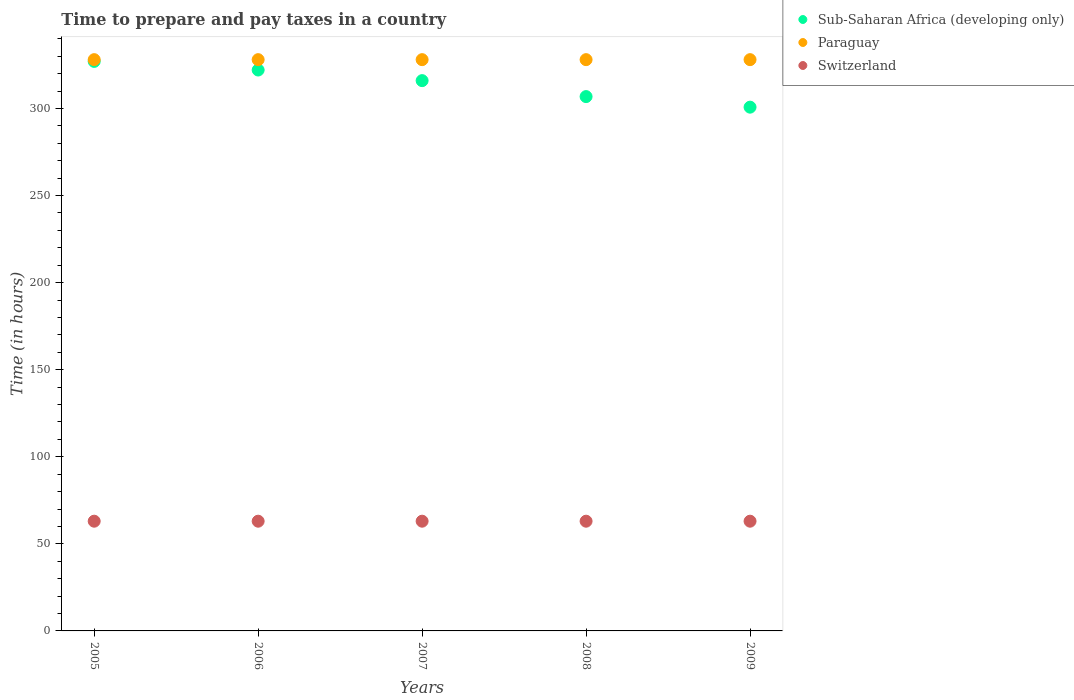How many different coloured dotlines are there?
Make the answer very short. 3. What is the number of hours required to prepare and pay taxes in Switzerland in 2006?
Offer a terse response. 63. Across all years, what is the maximum number of hours required to prepare and pay taxes in Sub-Saharan Africa (developing only)?
Make the answer very short. 327. Across all years, what is the minimum number of hours required to prepare and pay taxes in Sub-Saharan Africa (developing only)?
Your answer should be compact. 300.72. In which year was the number of hours required to prepare and pay taxes in Paraguay maximum?
Keep it short and to the point. 2005. What is the total number of hours required to prepare and pay taxes in Sub-Saharan Africa (developing only) in the graph?
Your answer should be very brief. 1572.51. What is the difference between the number of hours required to prepare and pay taxes in Switzerland in 2007 and that in 2008?
Offer a terse response. 0. What is the difference between the number of hours required to prepare and pay taxes in Switzerland in 2006 and the number of hours required to prepare and pay taxes in Paraguay in 2005?
Offer a very short reply. -265. What is the average number of hours required to prepare and pay taxes in Sub-Saharan Africa (developing only) per year?
Your response must be concise. 314.5. In the year 2006, what is the difference between the number of hours required to prepare and pay taxes in Sub-Saharan Africa (developing only) and number of hours required to prepare and pay taxes in Switzerland?
Offer a very short reply. 259.05. In how many years, is the number of hours required to prepare and pay taxes in Switzerland greater than 210 hours?
Give a very brief answer. 0. What is the ratio of the number of hours required to prepare and pay taxes in Paraguay in 2008 to that in 2009?
Your response must be concise. 1. Is the number of hours required to prepare and pay taxes in Paraguay in 2005 less than that in 2007?
Ensure brevity in your answer.  No. What is the difference between the highest and the lowest number of hours required to prepare and pay taxes in Switzerland?
Your answer should be compact. 0. In how many years, is the number of hours required to prepare and pay taxes in Paraguay greater than the average number of hours required to prepare and pay taxes in Paraguay taken over all years?
Make the answer very short. 0. Is the sum of the number of hours required to prepare and pay taxes in Switzerland in 2008 and 2009 greater than the maximum number of hours required to prepare and pay taxes in Sub-Saharan Africa (developing only) across all years?
Offer a terse response. No. Is the number of hours required to prepare and pay taxes in Sub-Saharan Africa (developing only) strictly greater than the number of hours required to prepare and pay taxes in Paraguay over the years?
Your answer should be very brief. No. How many dotlines are there?
Offer a very short reply. 3. What is the difference between two consecutive major ticks on the Y-axis?
Give a very brief answer. 50. Are the values on the major ticks of Y-axis written in scientific E-notation?
Offer a terse response. No. Where does the legend appear in the graph?
Your response must be concise. Top right. What is the title of the graph?
Provide a short and direct response. Time to prepare and pay taxes in a country. Does "Djibouti" appear as one of the legend labels in the graph?
Make the answer very short. No. What is the label or title of the X-axis?
Your answer should be compact. Years. What is the label or title of the Y-axis?
Give a very brief answer. Time (in hours). What is the Time (in hours) in Sub-Saharan Africa (developing only) in 2005?
Make the answer very short. 327. What is the Time (in hours) in Paraguay in 2005?
Keep it short and to the point. 328. What is the Time (in hours) of Sub-Saharan Africa (developing only) in 2006?
Give a very brief answer. 322.05. What is the Time (in hours) in Paraguay in 2006?
Your answer should be very brief. 328. What is the Time (in hours) in Switzerland in 2006?
Keep it short and to the point. 63. What is the Time (in hours) of Sub-Saharan Africa (developing only) in 2007?
Your answer should be very brief. 315.95. What is the Time (in hours) of Paraguay in 2007?
Provide a succinct answer. 328. What is the Time (in hours) of Switzerland in 2007?
Your response must be concise. 63. What is the Time (in hours) of Sub-Saharan Africa (developing only) in 2008?
Provide a succinct answer. 306.79. What is the Time (in hours) in Paraguay in 2008?
Your answer should be compact. 328. What is the Time (in hours) in Sub-Saharan Africa (developing only) in 2009?
Provide a short and direct response. 300.72. What is the Time (in hours) in Paraguay in 2009?
Give a very brief answer. 328. Across all years, what is the maximum Time (in hours) in Sub-Saharan Africa (developing only)?
Provide a short and direct response. 327. Across all years, what is the maximum Time (in hours) of Paraguay?
Keep it short and to the point. 328. Across all years, what is the maximum Time (in hours) of Switzerland?
Give a very brief answer. 63. Across all years, what is the minimum Time (in hours) in Sub-Saharan Africa (developing only)?
Offer a very short reply. 300.72. Across all years, what is the minimum Time (in hours) in Paraguay?
Your answer should be compact. 328. What is the total Time (in hours) in Sub-Saharan Africa (developing only) in the graph?
Provide a short and direct response. 1572.51. What is the total Time (in hours) of Paraguay in the graph?
Make the answer very short. 1640. What is the total Time (in hours) of Switzerland in the graph?
Your answer should be compact. 315. What is the difference between the Time (in hours) of Sub-Saharan Africa (developing only) in 2005 and that in 2006?
Your answer should be very brief. 4.95. What is the difference between the Time (in hours) of Switzerland in 2005 and that in 2006?
Ensure brevity in your answer.  0. What is the difference between the Time (in hours) of Sub-Saharan Africa (developing only) in 2005 and that in 2007?
Make the answer very short. 11.05. What is the difference between the Time (in hours) of Sub-Saharan Africa (developing only) in 2005 and that in 2008?
Your answer should be very brief. 20.21. What is the difference between the Time (in hours) in Paraguay in 2005 and that in 2008?
Provide a succinct answer. 0. What is the difference between the Time (in hours) in Sub-Saharan Africa (developing only) in 2005 and that in 2009?
Your answer should be very brief. 26.28. What is the difference between the Time (in hours) in Paraguay in 2005 and that in 2009?
Your response must be concise. 0. What is the difference between the Time (in hours) in Switzerland in 2005 and that in 2009?
Offer a terse response. 0. What is the difference between the Time (in hours) in Sub-Saharan Africa (developing only) in 2006 and that in 2007?
Your answer should be compact. 6.09. What is the difference between the Time (in hours) in Paraguay in 2006 and that in 2007?
Your answer should be compact. 0. What is the difference between the Time (in hours) of Sub-Saharan Africa (developing only) in 2006 and that in 2008?
Your answer should be very brief. 15.26. What is the difference between the Time (in hours) of Paraguay in 2006 and that in 2008?
Your answer should be very brief. 0. What is the difference between the Time (in hours) in Switzerland in 2006 and that in 2008?
Offer a terse response. 0. What is the difference between the Time (in hours) of Sub-Saharan Africa (developing only) in 2006 and that in 2009?
Offer a terse response. 21.33. What is the difference between the Time (in hours) of Sub-Saharan Africa (developing only) in 2007 and that in 2008?
Your response must be concise. 9.16. What is the difference between the Time (in hours) of Paraguay in 2007 and that in 2008?
Offer a very short reply. 0. What is the difference between the Time (in hours) of Sub-Saharan Africa (developing only) in 2007 and that in 2009?
Offer a very short reply. 15.23. What is the difference between the Time (in hours) of Sub-Saharan Africa (developing only) in 2008 and that in 2009?
Make the answer very short. 6.07. What is the difference between the Time (in hours) in Switzerland in 2008 and that in 2009?
Offer a very short reply. 0. What is the difference between the Time (in hours) of Sub-Saharan Africa (developing only) in 2005 and the Time (in hours) of Paraguay in 2006?
Give a very brief answer. -1. What is the difference between the Time (in hours) in Sub-Saharan Africa (developing only) in 2005 and the Time (in hours) in Switzerland in 2006?
Offer a very short reply. 264. What is the difference between the Time (in hours) of Paraguay in 2005 and the Time (in hours) of Switzerland in 2006?
Ensure brevity in your answer.  265. What is the difference between the Time (in hours) of Sub-Saharan Africa (developing only) in 2005 and the Time (in hours) of Switzerland in 2007?
Make the answer very short. 264. What is the difference between the Time (in hours) of Paraguay in 2005 and the Time (in hours) of Switzerland in 2007?
Provide a succinct answer. 265. What is the difference between the Time (in hours) of Sub-Saharan Africa (developing only) in 2005 and the Time (in hours) of Switzerland in 2008?
Provide a short and direct response. 264. What is the difference between the Time (in hours) of Paraguay in 2005 and the Time (in hours) of Switzerland in 2008?
Keep it short and to the point. 265. What is the difference between the Time (in hours) in Sub-Saharan Africa (developing only) in 2005 and the Time (in hours) in Switzerland in 2009?
Provide a short and direct response. 264. What is the difference between the Time (in hours) of Paraguay in 2005 and the Time (in hours) of Switzerland in 2009?
Make the answer very short. 265. What is the difference between the Time (in hours) of Sub-Saharan Africa (developing only) in 2006 and the Time (in hours) of Paraguay in 2007?
Your answer should be compact. -5.95. What is the difference between the Time (in hours) in Sub-Saharan Africa (developing only) in 2006 and the Time (in hours) in Switzerland in 2007?
Give a very brief answer. 259.05. What is the difference between the Time (in hours) in Paraguay in 2006 and the Time (in hours) in Switzerland in 2007?
Make the answer very short. 265. What is the difference between the Time (in hours) of Sub-Saharan Africa (developing only) in 2006 and the Time (in hours) of Paraguay in 2008?
Make the answer very short. -5.95. What is the difference between the Time (in hours) in Sub-Saharan Africa (developing only) in 2006 and the Time (in hours) in Switzerland in 2008?
Offer a terse response. 259.05. What is the difference between the Time (in hours) in Paraguay in 2006 and the Time (in hours) in Switzerland in 2008?
Make the answer very short. 265. What is the difference between the Time (in hours) of Sub-Saharan Africa (developing only) in 2006 and the Time (in hours) of Paraguay in 2009?
Give a very brief answer. -5.95. What is the difference between the Time (in hours) in Sub-Saharan Africa (developing only) in 2006 and the Time (in hours) in Switzerland in 2009?
Your response must be concise. 259.05. What is the difference between the Time (in hours) of Paraguay in 2006 and the Time (in hours) of Switzerland in 2009?
Your answer should be compact. 265. What is the difference between the Time (in hours) in Sub-Saharan Africa (developing only) in 2007 and the Time (in hours) in Paraguay in 2008?
Make the answer very short. -12.05. What is the difference between the Time (in hours) in Sub-Saharan Africa (developing only) in 2007 and the Time (in hours) in Switzerland in 2008?
Offer a terse response. 252.95. What is the difference between the Time (in hours) of Paraguay in 2007 and the Time (in hours) of Switzerland in 2008?
Give a very brief answer. 265. What is the difference between the Time (in hours) in Sub-Saharan Africa (developing only) in 2007 and the Time (in hours) in Paraguay in 2009?
Provide a short and direct response. -12.05. What is the difference between the Time (in hours) of Sub-Saharan Africa (developing only) in 2007 and the Time (in hours) of Switzerland in 2009?
Provide a short and direct response. 252.95. What is the difference between the Time (in hours) of Paraguay in 2007 and the Time (in hours) of Switzerland in 2009?
Ensure brevity in your answer.  265. What is the difference between the Time (in hours) in Sub-Saharan Africa (developing only) in 2008 and the Time (in hours) in Paraguay in 2009?
Give a very brief answer. -21.21. What is the difference between the Time (in hours) in Sub-Saharan Africa (developing only) in 2008 and the Time (in hours) in Switzerland in 2009?
Your answer should be very brief. 243.79. What is the difference between the Time (in hours) in Paraguay in 2008 and the Time (in hours) in Switzerland in 2009?
Ensure brevity in your answer.  265. What is the average Time (in hours) in Sub-Saharan Africa (developing only) per year?
Give a very brief answer. 314.5. What is the average Time (in hours) in Paraguay per year?
Your answer should be very brief. 328. What is the average Time (in hours) of Switzerland per year?
Make the answer very short. 63. In the year 2005, what is the difference between the Time (in hours) of Sub-Saharan Africa (developing only) and Time (in hours) of Switzerland?
Make the answer very short. 264. In the year 2005, what is the difference between the Time (in hours) of Paraguay and Time (in hours) of Switzerland?
Give a very brief answer. 265. In the year 2006, what is the difference between the Time (in hours) in Sub-Saharan Africa (developing only) and Time (in hours) in Paraguay?
Offer a very short reply. -5.95. In the year 2006, what is the difference between the Time (in hours) in Sub-Saharan Africa (developing only) and Time (in hours) in Switzerland?
Offer a very short reply. 259.05. In the year 2006, what is the difference between the Time (in hours) of Paraguay and Time (in hours) of Switzerland?
Your response must be concise. 265. In the year 2007, what is the difference between the Time (in hours) in Sub-Saharan Africa (developing only) and Time (in hours) in Paraguay?
Your answer should be compact. -12.05. In the year 2007, what is the difference between the Time (in hours) of Sub-Saharan Africa (developing only) and Time (in hours) of Switzerland?
Provide a short and direct response. 252.95. In the year 2007, what is the difference between the Time (in hours) in Paraguay and Time (in hours) in Switzerland?
Give a very brief answer. 265. In the year 2008, what is the difference between the Time (in hours) in Sub-Saharan Africa (developing only) and Time (in hours) in Paraguay?
Give a very brief answer. -21.21. In the year 2008, what is the difference between the Time (in hours) of Sub-Saharan Africa (developing only) and Time (in hours) of Switzerland?
Ensure brevity in your answer.  243.79. In the year 2008, what is the difference between the Time (in hours) in Paraguay and Time (in hours) in Switzerland?
Your answer should be compact. 265. In the year 2009, what is the difference between the Time (in hours) of Sub-Saharan Africa (developing only) and Time (in hours) of Paraguay?
Offer a very short reply. -27.28. In the year 2009, what is the difference between the Time (in hours) of Sub-Saharan Africa (developing only) and Time (in hours) of Switzerland?
Ensure brevity in your answer.  237.72. In the year 2009, what is the difference between the Time (in hours) in Paraguay and Time (in hours) in Switzerland?
Your answer should be compact. 265. What is the ratio of the Time (in hours) of Sub-Saharan Africa (developing only) in 2005 to that in 2006?
Your response must be concise. 1.02. What is the ratio of the Time (in hours) of Paraguay in 2005 to that in 2006?
Give a very brief answer. 1. What is the ratio of the Time (in hours) of Switzerland in 2005 to that in 2006?
Your answer should be compact. 1. What is the ratio of the Time (in hours) of Sub-Saharan Africa (developing only) in 2005 to that in 2007?
Provide a succinct answer. 1.03. What is the ratio of the Time (in hours) of Sub-Saharan Africa (developing only) in 2005 to that in 2008?
Your answer should be compact. 1.07. What is the ratio of the Time (in hours) in Sub-Saharan Africa (developing only) in 2005 to that in 2009?
Give a very brief answer. 1.09. What is the ratio of the Time (in hours) in Switzerland in 2005 to that in 2009?
Offer a very short reply. 1. What is the ratio of the Time (in hours) in Sub-Saharan Africa (developing only) in 2006 to that in 2007?
Ensure brevity in your answer.  1.02. What is the ratio of the Time (in hours) of Paraguay in 2006 to that in 2007?
Keep it short and to the point. 1. What is the ratio of the Time (in hours) in Switzerland in 2006 to that in 2007?
Offer a terse response. 1. What is the ratio of the Time (in hours) in Sub-Saharan Africa (developing only) in 2006 to that in 2008?
Your answer should be compact. 1.05. What is the ratio of the Time (in hours) of Paraguay in 2006 to that in 2008?
Your answer should be compact. 1. What is the ratio of the Time (in hours) of Sub-Saharan Africa (developing only) in 2006 to that in 2009?
Provide a succinct answer. 1.07. What is the ratio of the Time (in hours) in Paraguay in 2006 to that in 2009?
Your response must be concise. 1. What is the ratio of the Time (in hours) in Switzerland in 2006 to that in 2009?
Keep it short and to the point. 1. What is the ratio of the Time (in hours) of Sub-Saharan Africa (developing only) in 2007 to that in 2008?
Offer a terse response. 1.03. What is the ratio of the Time (in hours) in Paraguay in 2007 to that in 2008?
Give a very brief answer. 1. What is the ratio of the Time (in hours) in Sub-Saharan Africa (developing only) in 2007 to that in 2009?
Your answer should be compact. 1.05. What is the ratio of the Time (in hours) in Paraguay in 2007 to that in 2009?
Give a very brief answer. 1. What is the ratio of the Time (in hours) in Switzerland in 2007 to that in 2009?
Keep it short and to the point. 1. What is the ratio of the Time (in hours) in Sub-Saharan Africa (developing only) in 2008 to that in 2009?
Your answer should be very brief. 1.02. What is the ratio of the Time (in hours) of Paraguay in 2008 to that in 2009?
Keep it short and to the point. 1. What is the ratio of the Time (in hours) of Switzerland in 2008 to that in 2009?
Your answer should be compact. 1. What is the difference between the highest and the second highest Time (in hours) in Sub-Saharan Africa (developing only)?
Offer a very short reply. 4.95. What is the difference between the highest and the second highest Time (in hours) in Switzerland?
Your answer should be compact. 0. What is the difference between the highest and the lowest Time (in hours) in Sub-Saharan Africa (developing only)?
Ensure brevity in your answer.  26.28. What is the difference between the highest and the lowest Time (in hours) in Switzerland?
Give a very brief answer. 0. 